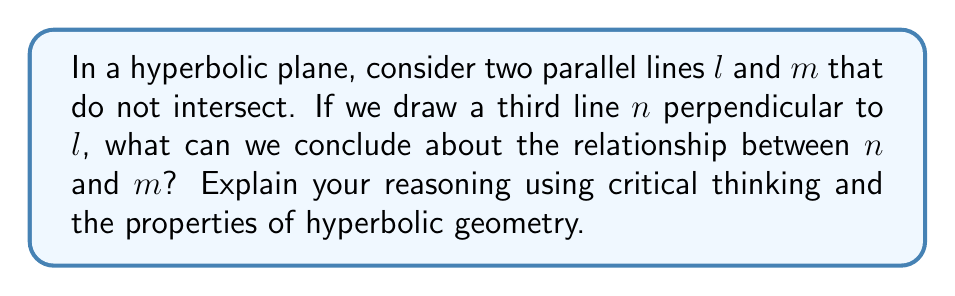Can you solve this math problem? Let's approach this step-by-step using the properties of hyperbolic geometry:

1) In Euclidean geometry, if two lines are parallel and a third line is perpendicular to one of them, it would also be perpendicular to the other. However, hyperbolic geometry doesn't follow this rule.

2) In hyperbolic geometry, parallel lines have a unique property:
   - They diverge from each other in both directions.
   - The distance between them increases exponentially as you move along either line.

3) Consider the perpendicular line $n$ to $l$:
   [asy]
   import geometry;
   
   size(200);
   
   path hyperbolaLeft = graph(new real(real x){return -sqrt(1+x^2);}, -2, 2);
   path hyperbolaRight = graph(new real(real x){return sqrt(1+x^2);}, -2, 2);
   
   draw(hyperbolaLeft, blue);
   draw(hyperbolaRight, blue);
   draw((-2,0)--(2,0), red);
   draw((0,-2)--(0,2), green);
   
   label("$l$", (2,0), E);
   label("$m$", (2,sqrt(5)), E);
   label("$n$", (0,2), N);
   
   dot((0,0));
   [/asy]

4) Due to the divergent nature of parallel lines in hyperbolic geometry:
   - As $n$ extends beyond $l$, it will curve away from $m$.
   - This curvature is a result of the hyperbolic plane's negative curvature.

5) Consequently, $n$ will not intersect $m$ at a right angle. In fact, it won't intersect $m$ at all.

6) The angle between $n$ and $m$ (if extended to intersect) would be less than 90°.

This result challenges our Euclidean intuition and exemplifies why critical thinking is crucial when exploring non-Euclidean geometries. It demonstrates that parallel lines in hyperbolic geometry behave fundamentally differently from those in Euclidean geometry.
Answer: $n$ is not perpendicular to $m$ and does not intersect it. 